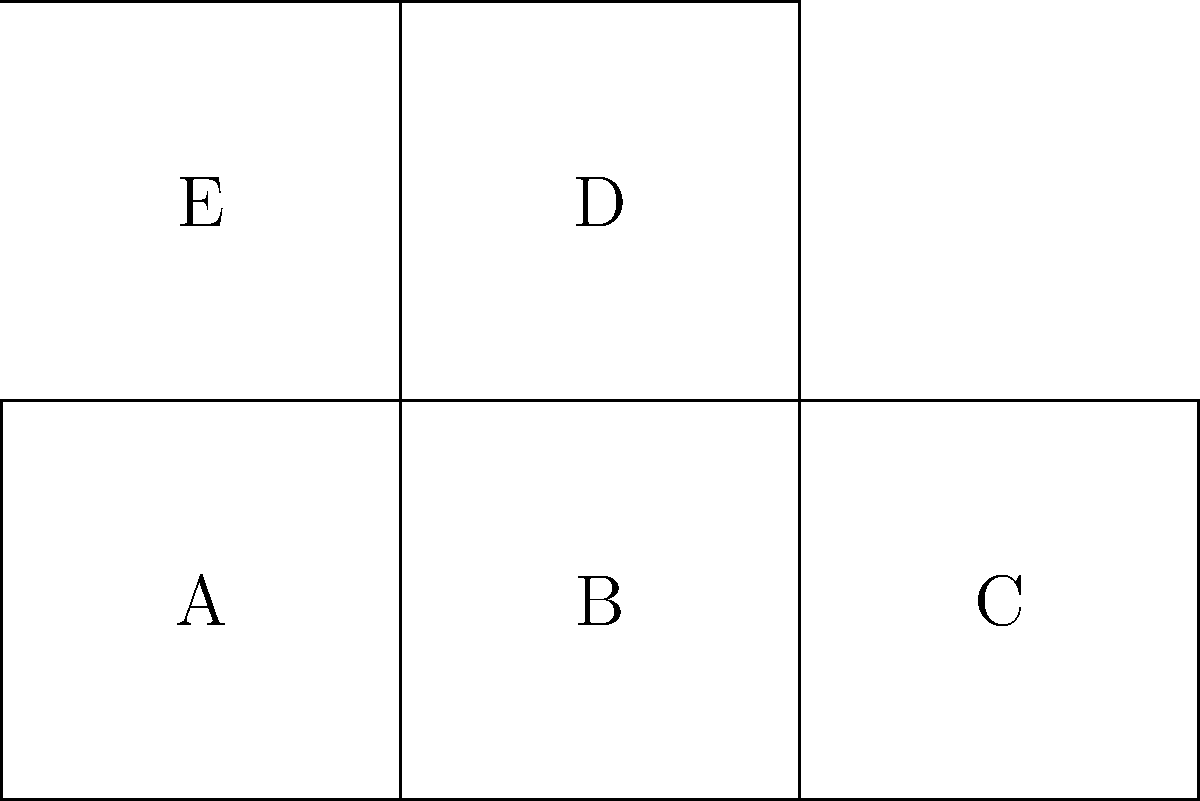Consider the 2D pattern shown above, which represents an unfolded cube. Each face is labeled with a letter (A, B, C, D, E). If this pattern is folded along the dashed lines to form a cube, which face will be directly opposite to face A? To determine which face will be opposite to face A when the pattern is folded into a cube, let's follow these steps:

1. Visualize the folding process:
   - Faces B and C will fold up to form the sides of the cube.
   - Faces D and E will fold up to form the top and back of the cube.

2. Analyze the relative positions:
   - Face A will form the bottom of the cube.
   - Face B will be adjacent to A on one side.
   - Face C will be adjacent to A on another side.
   - Face E will be adjacent to A at the back.

3. Identify the opposite face:
   - In a cube, opposite faces are those that do not share any edges.
   - The only face that does not share an edge with A in the folded state is D.

4. Confirm the result:
   - Face D will indeed be on top of the cube when A is at the bottom.
   - This satisfies the definition of opposite faces in a cube.

Therefore, when the pattern is folded into a cube, face D will be directly opposite to face A.
Answer: D 